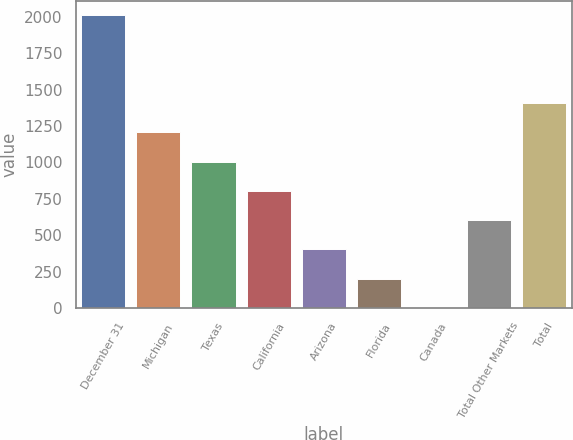<chart> <loc_0><loc_0><loc_500><loc_500><bar_chart><fcel>December 31<fcel>Michigan<fcel>Texas<fcel>California<fcel>Arizona<fcel>Florida<fcel>Canada<fcel>Total Other Markets<fcel>Total<nl><fcel>2011<fcel>1207<fcel>1006<fcel>805<fcel>403<fcel>202<fcel>1<fcel>604<fcel>1408<nl></chart> 